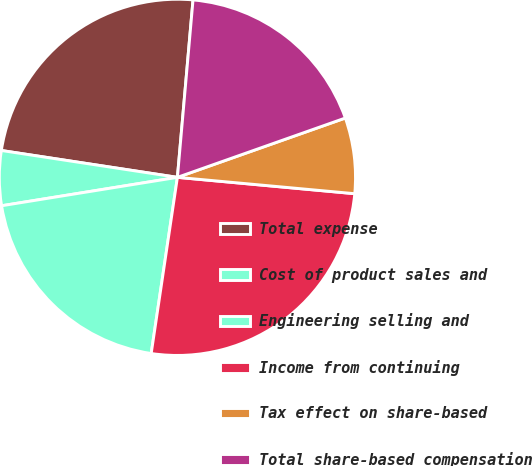Convert chart to OTSL. <chart><loc_0><loc_0><loc_500><loc_500><pie_chart><fcel>Total expense<fcel>Cost of product sales and<fcel>Engineering selling and<fcel>Income from continuing<fcel>Tax effect on share-based<fcel>Total share-based compensation<nl><fcel>23.99%<fcel>4.96%<fcel>20.1%<fcel>25.89%<fcel>6.87%<fcel>18.2%<nl></chart> 